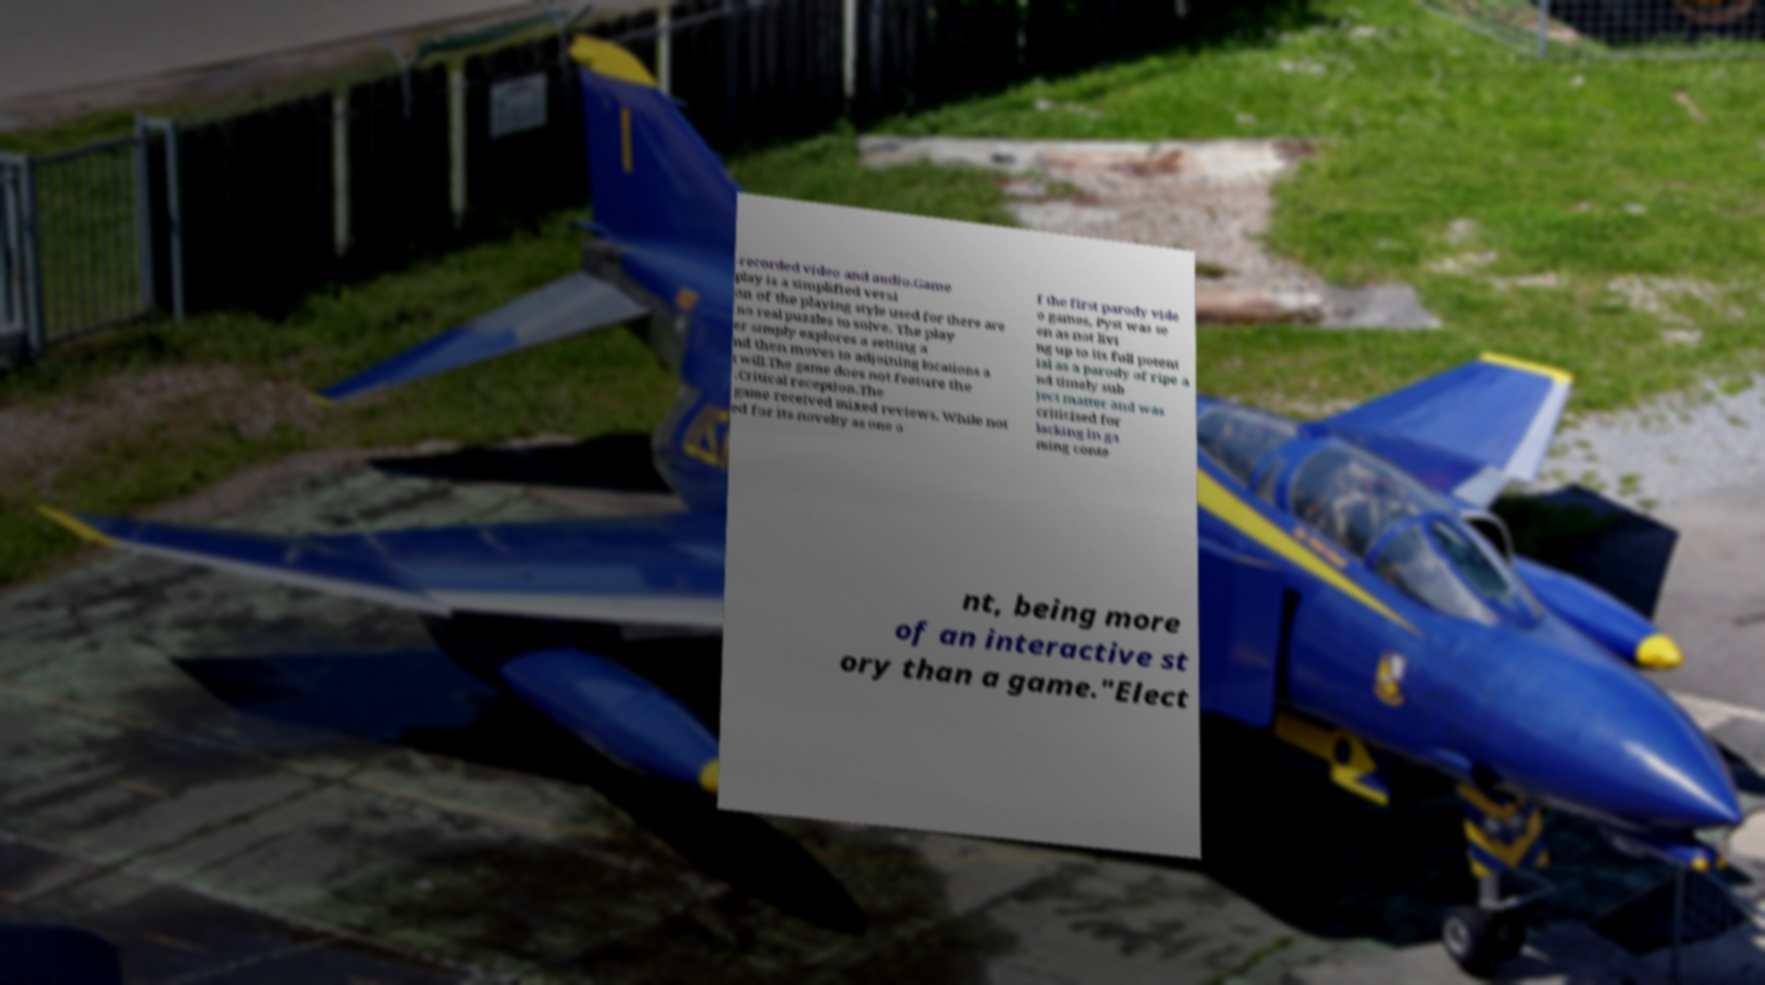Please read and relay the text visible in this image. What does it say? -recorded video and audio.Game play is a simplified versi on of the playing style used for there are no real puzzles to solve. The play er simply explores a setting a nd then moves to adjoining locations a t will.The game does not feature the .Critical reception.The game received mixed reviews. While not ed for its novelty as one o f the first parody vide o games, Pyst was se en as not livi ng up to its full potent ial as a parody of ripe a nd timely sub ject matter and was criticised for lacking in ga ming conte nt, being more of an interactive st ory than a game."Elect 